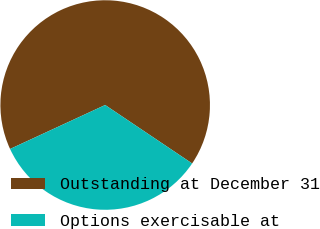<chart> <loc_0><loc_0><loc_500><loc_500><pie_chart><fcel>Outstanding at December 31<fcel>Options exercisable at<nl><fcel>66.31%<fcel>33.69%<nl></chart> 